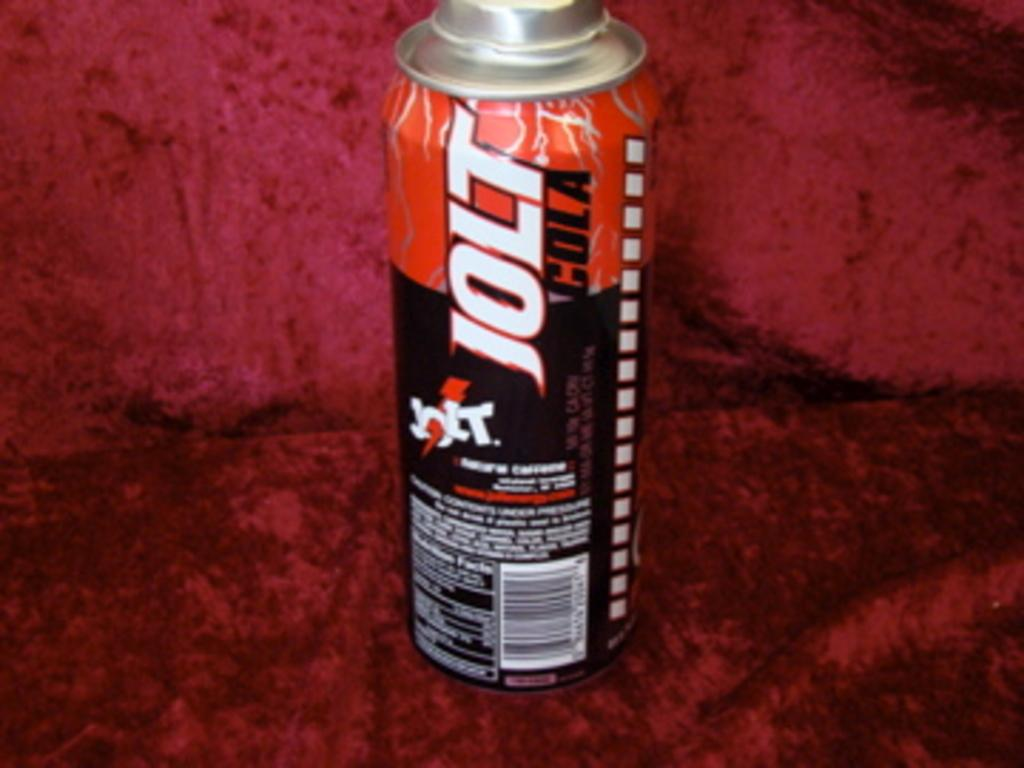<image>
Present a compact description of the photo's key features. the word jolt that is on a can 